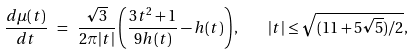Convert formula to latex. <formula><loc_0><loc_0><loc_500><loc_500>\frac { d \mu ( t ) } { d t } \ = \ \frac { \sqrt { 3 } } { 2 \pi | t | } \left ( \frac { 3 t ^ { 2 } + 1 } { 9 h ( t ) } - h ( t ) \right ) , \quad | t | \leq \sqrt { ( 1 1 + 5 \sqrt { 5 } ) / 2 } ,</formula> 